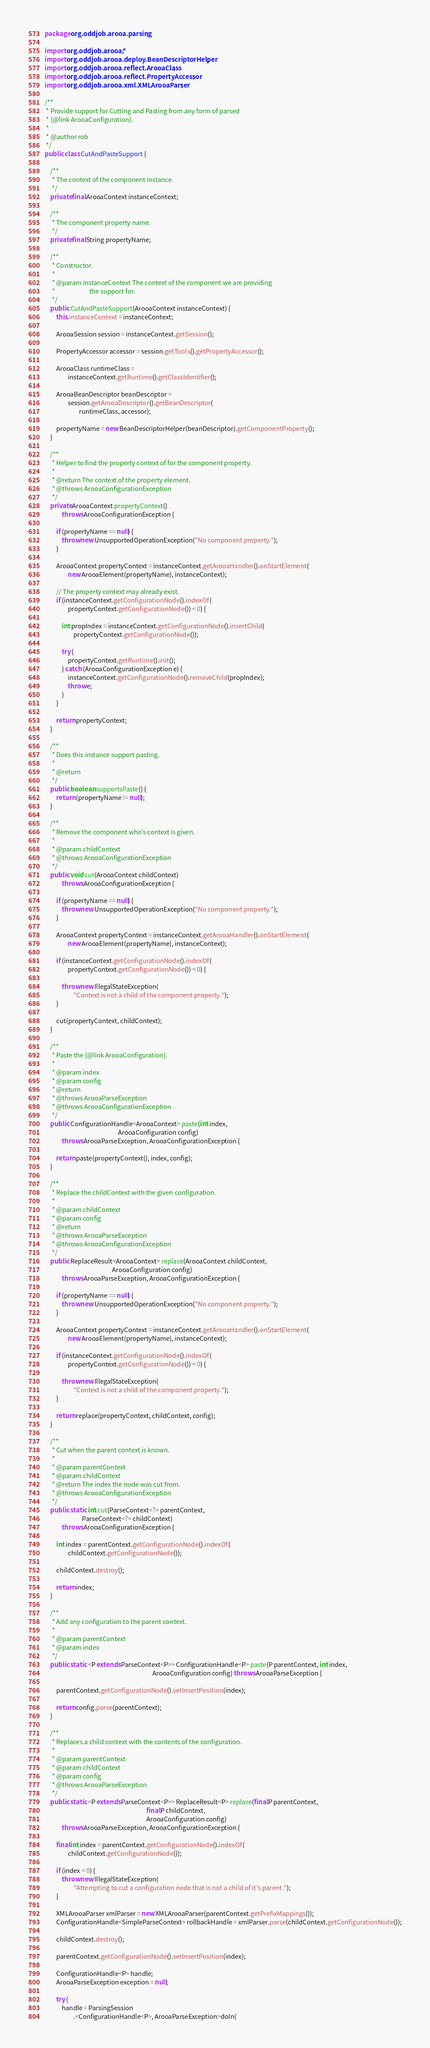<code> <loc_0><loc_0><loc_500><loc_500><_Java_>package org.oddjob.arooa.parsing;

import org.oddjob.arooa.*;
import org.oddjob.arooa.deploy.BeanDescriptorHelper;
import org.oddjob.arooa.reflect.ArooaClass;
import org.oddjob.arooa.reflect.PropertyAccessor;
import org.oddjob.arooa.xml.XMLArooaParser;

/**
 * Provide support for Cutting and Pasting from any form of parsed
 * {@link ArooaConfiguration}.
 *
 * @author rob
 */
public class CutAndPasteSupport {

    /**
     * The context of the component instance.
     */
    private final ArooaContext instanceContext;

    /**
     * The component property name.
     */
    private final String propertyName;

    /**
     * Constructor.
     *
     * @param instanceContext The context of the component we are providing
     *                        the support for.
     */
    public CutAndPasteSupport(ArooaContext instanceContext) {
        this.instanceContext = instanceContext;

        ArooaSession session = instanceContext.getSession();

        PropertyAccessor accessor = session.getTools().getPropertyAccessor();

        ArooaClass runtimeClass =
                instanceContext.getRuntime().getClassIdentifier();

        ArooaBeanDescriptor beanDescriptor =
                session.getArooaDescriptor().getBeanDescriptor(
                        runtimeClass, accessor);

        propertyName = new BeanDescriptorHelper(beanDescriptor).getComponentProperty();
    }

    /**
     * Helper to find the property context of for the component property.
     *
     * @return The context of the property element.
     * @throws ArooaConfigurationException
     */
    private ArooaContext propertyContext()
            throws ArooaConfigurationException {

        if (propertyName == null) {
            throw new UnsupportedOperationException("No component property.");
        }

        ArooaContext propertyContext = instanceContext.getArooaHandler().onStartElement(
                new ArooaElement(propertyName), instanceContext);

        // The property context may already exist.
        if (instanceContext.getConfigurationNode().indexOf(
                propertyContext.getConfigurationNode()) < 0) {

            int propIndex = instanceContext.getConfigurationNode().insertChild(
                    propertyContext.getConfigurationNode());

            try {
                propertyContext.getRuntime().init();
            } catch (ArooaConfigurationException e) {
                instanceContext.getConfigurationNode().removeChild(propIndex);
                throw e;
            }
        }

        return propertyContext;
    }

    /**
     * Does this instance support pasting.
     *
     * @return
     */
    public boolean supportsPaste() {
        return (propertyName != null);
    }

    /**
     * Remove the component who's context is given.
     *
     * @param childContext
     * @throws ArooaConfigurationException
     */
    public void cut(ArooaContext childContext)
            throws ArooaConfigurationException {

        if (propertyName == null) {
            throw new UnsupportedOperationException("No component property.");
        }

        ArooaContext propertyContext = instanceContext.getArooaHandler().onStartElement(
                new ArooaElement(propertyName), instanceContext);

        if (instanceContext.getConfigurationNode().indexOf(
                propertyContext.getConfigurationNode()) < 0) {

            throw new IllegalStateException(
                    "Context is not a child of the component property.");
        }

        cut(propertyContext, childContext);
    }

    /**
     * Paste the {@link ArooaConfiguration}.
     *
     * @param index
     * @param config
     * @return
     * @throws ArooaParseException
     * @throws ArooaConfigurationException
     */
    public ConfigurationHandle<ArooaContext> paste(int index,
                                                   ArooaConfiguration config)
            throws ArooaParseException, ArooaConfigurationException {

        return paste(propertyContext(), index, config);
    }

    /**
     * Replace the childContext with the given configuration.
     *
     * @param childContext
     * @param config
     * @return
     * @throws ArooaParseException
     * @throws ArooaConfigurationException
     */
    public ReplaceResult<ArooaContext> replace(ArooaContext childContext,
                                               ArooaConfiguration config)
            throws ArooaParseException, ArooaConfigurationException {

        if (propertyName == null) {
            throw new UnsupportedOperationException("No component property.");
        }

        ArooaContext propertyContext = instanceContext.getArooaHandler().onStartElement(
                new ArooaElement(propertyName), instanceContext);

        if (instanceContext.getConfigurationNode().indexOf(
                propertyContext.getConfigurationNode()) < 0) {

            throw new IllegalStateException(
                    "Context is not a child of the component property.");
        }

        return replace(propertyContext, childContext, config);
    }

    /**
     * Cut when the parent context is known.
     *
     * @param parentContext
     * @param childContext
     * @return The index the node was cut from.
     * @throws ArooaConfigurationException
     */
    public static int cut(ParseContext<?> parentContext,
                          ParseContext<?> childContext)
            throws ArooaConfigurationException {

        int index = parentContext.getConfigurationNode().indexOf(
                childContext.getConfigurationNode());

        childContext.destroy();

        return index;
    }

    /**
     * Add any configuration to the parent context.
     *
     * @param parentContext
     * @param index
     */
    public static <P extends ParseContext<P>> ConfigurationHandle<P> paste(P parentContext, int index,
                                                                           ArooaConfiguration config) throws ArooaParseException {

        parentContext.getConfigurationNode().setInsertPosition(index);

        return config.parse(parentContext);
    }

    /**
     * Replaces a child context with the contents of the configuration.
     *
     * @param parentContext
     * @param childContext
     * @param config
     * @throws ArooaParseException
     */
    public static <P extends ParseContext<P>> ReplaceResult<P> replace(final P parentContext,
                                                                       final P childContext,
                                                                       ArooaConfiguration config)
            throws ArooaParseException, ArooaConfigurationException {

        final int index = parentContext.getConfigurationNode().indexOf(
                childContext.getConfigurationNode());

        if (index < 0) {
            throw new IllegalStateException(
                    "Attempting to cut a configuration node that is not a child of it's parent.");
        }

        XMLArooaParser xmlParser = new XMLArooaParser(parentContext.getPrefixMappings());
        ConfigurationHandle<SimpleParseContext> rollbackHandle = xmlParser.parse(childContext.getConfigurationNode());

        childContext.destroy();

        parentContext.getConfigurationNode().setInsertPosition(index);

        ConfigurationHandle<P> handle;
        ArooaParseException exception = null;

        try {
            handle = ParsingSession
                    .<ConfigurationHandle<P>, ArooaParseException>doIn(</code> 